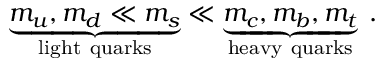Convert formula to latex. <formula><loc_0><loc_0><loc_500><loc_500>\underbrace { m _ { u } , m _ { d } \ll m _ { s } } _ { l i g h t q u a r k s } \ll \underbrace { m _ { c } , m _ { b } , m _ { t } } _ { h e a v y q u a r k s } \, .</formula> 